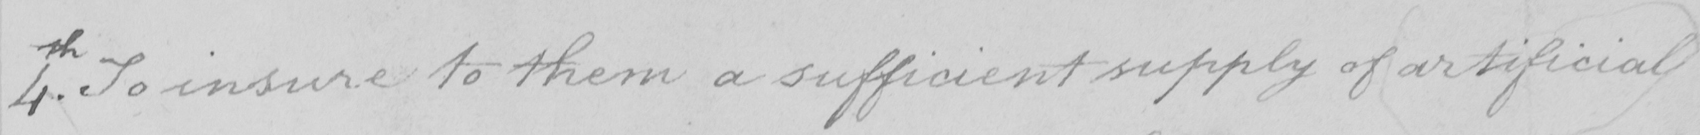What does this handwritten line say? 4th . To insure to them a sufficient supply of artificial 